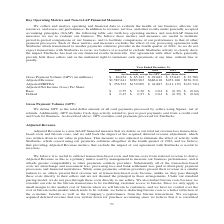According to Square's financial document, What does GAAP stand for? generally accepted accounting principles. The document states: "ion to revenue, net loss, and other results under generally accepted accounting principles (GAAP), the following table sets forth key operating metric..." Also, What is the definition of GPV? total dollar amount of all card payments processed by sellers using Square, net of refunds. The document states: "We define GPV as the total dollar amount of all card payments processed by sellers using Square, net of refunds. Additionally, GPV includes Cash App a..." Also, What does GPV include? Cash App activity related to peer-to-peer payments sent from a credit card and Cash for Business. The document states: "quare, net of refunds. Additionally, GPV includes Cash App activity related to peer-to-peer payments sent from a credit card and Cash for Business. As..." Also, can you calculate: What is the percentage change of GPV from 2017 to 2018? To answer this question, I need to perform calculations using the financial data. The calculation is: (84,654 - 65,343) / 65,343 , which equals 29.55 (percentage). This is based on the information: "data) Gross Payment Volume (GPV) (in millions) $ 84,654 $ 65,343 $ 49,683 $ 35,643 $ 23,780 Adjusted Revenue $1,587,641 $983,963 $686,618 $452,168 $276,310 oss Payment Volume (GPV) (in millions) $ 84,..." The key data points involved are: 65,343, 84,654. Also, can you calculate: What is the percentage change of Adjusted Revenue from 2016 to 2017? To answer this question, I need to perform calculations using the financial data. The calculation is: (983,963 - 686,618) / 686,618 , which equals 43.31 (percentage). This is based on the information: "43 $ 23,780 Adjusted Revenue $1,587,641 $983,963 $686,618 $452,168 $276,310 Adjusted EBITDA $ 256,523 $139,009 $ 44,887 $ (41,115) $ (67,741) Adjusted Net In 83 $ 35,643 $ 23,780 Adjusted Revenue $1,5..." The key data points involved are: 686,618, 983,963. Also, can you calculate: How much is the change of adjusted EBITDA from 2015 to 2016? Based on the calculation: 44,887 - (-41,115) , the result is 86002 (in thousands). This is based on the information: "168 $276,310 Adjusted EBITDA $ 256,523 $139,009 $ 44,887 $ (41,115) $ (67,741) Adjusted Net Income (Loss) Per Share: Basic $ 0.55 $ 0.30 $ 0.04 $ (0.39) $ ( 10 Adjusted EBITDA $ 256,523 $139,009 $ 44,..." The key data points involved are: 41,115, 44,887. 